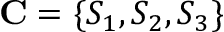<formula> <loc_0><loc_0><loc_500><loc_500>C = \{ S _ { 1 } , S _ { 2 } , S _ { 3 } \}</formula> 